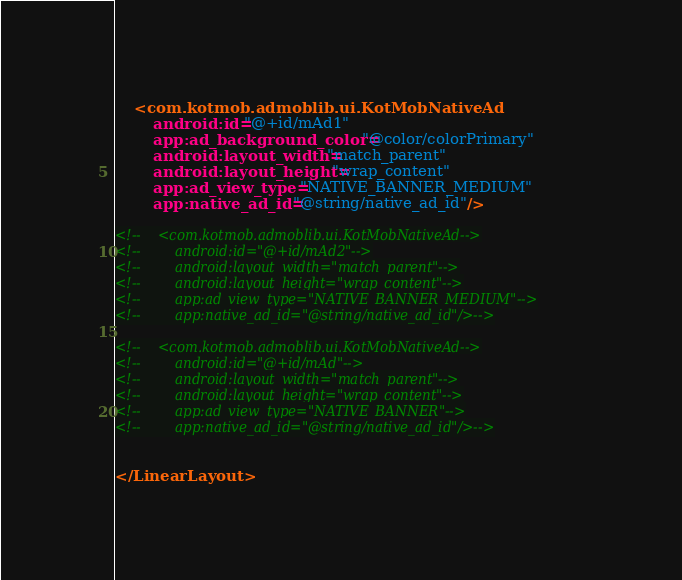<code> <loc_0><loc_0><loc_500><loc_500><_XML_>    <com.kotmob.admoblib.ui.KotMobNativeAd
        android:id="@+id/mAd1"
        app:ad_background_color="@color/colorPrimary"
        android:layout_width="match_parent"
        android:layout_height="wrap_content"
        app:ad_view_type="NATIVE_BANNER_MEDIUM"
        app:native_ad_id="@string/native_ad_id"/>

<!--    <com.kotmob.admoblib.ui.KotMobNativeAd-->
<!--        android:id="@+id/mAd2"-->
<!--        android:layout_width="match_parent"-->
<!--        android:layout_height="wrap_content"-->
<!--        app:ad_view_type="NATIVE_BANNER_MEDIUM"-->
<!--        app:native_ad_id="@string/native_ad_id"/>-->

<!--    <com.kotmob.admoblib.ui.KotMobNativeAd-->
<!--        android:id="@+id/mAd"-->
<!--        android:layout_width="match_parent"-->
<!--        android:layout_height="wrap_content"-->
<!--        app:ad_view_type="NATIVE_BANNER"-->
<!--        app:native_ad_id="@string/native_ad_id"/>-->


</LinearLayout></code> 